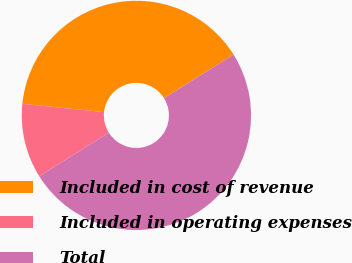<chart> <loc_0><loc_0><loc_500><loc_500><pie_chart><fcel>Included in cost of revenue<fcel>Included in operating expenses<fcel>Total<nl><fcel>39.48%<fcel>10.52%<fcel>50.0%<nl></chart> 